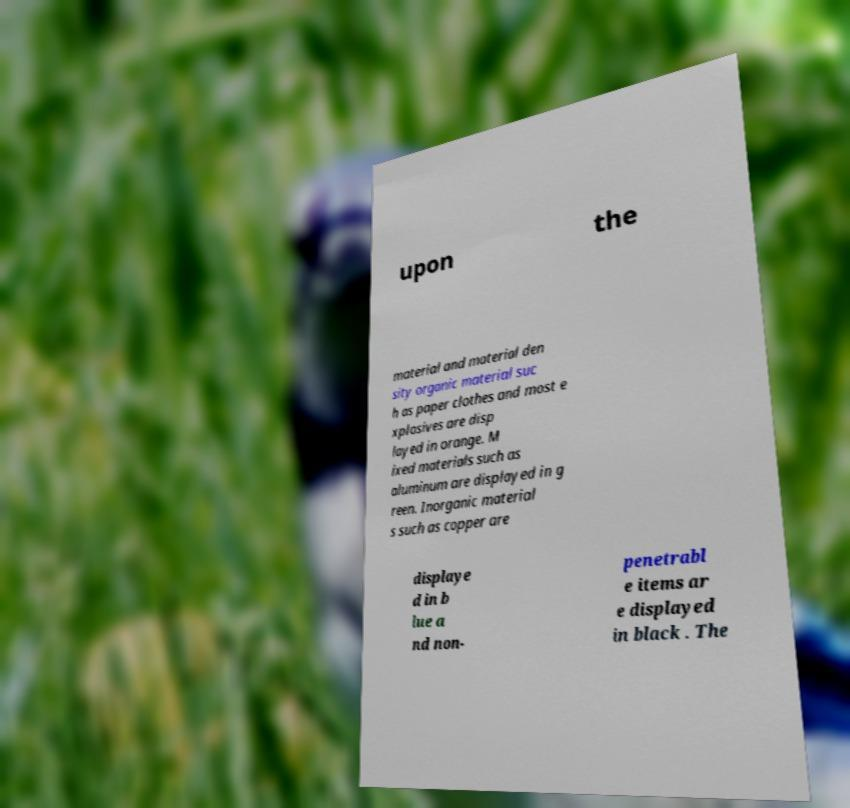I need the written content from this picture converted into text. Can you do that? upon the material and material den sity organic material suc h as paper clothes and most e xplosives are disp layed in orange. M ixed materials such as aluminum are displayed in g reen. Inorganic material s such as copper are displaye d in b lue a nd non- penetrabl e items ar e displayed in black . The 